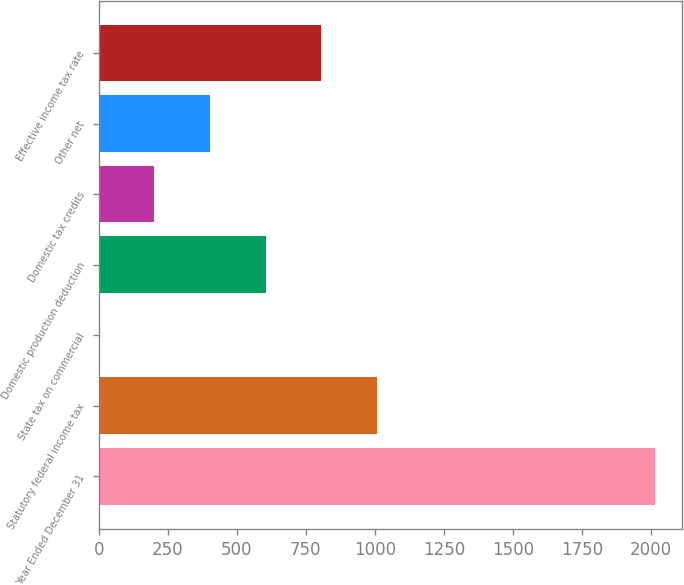<chart> <loc_0><loc_0><loc_500><loc_500><bar_chart><fcel>Year Ended December 31<fcel>Statutory federal income tax<fcel>State tax on commercial<fcel>Domestic production deduction<fcel>Domestic tax credits<fcel>Other net<fcel>Effective income tax rate<nl><fcel>2013<fcel>1006.85<fcel>0.7<fcel>604.39<fcel>201.93<fcel>403.16<fcel>805.62<nl></chart> 